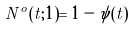<formula> <loc_0><loc_0><loc_500><loc_500>N ^ { o } ( t ; 1 ) = 1 - \psi ( t )</formula> 